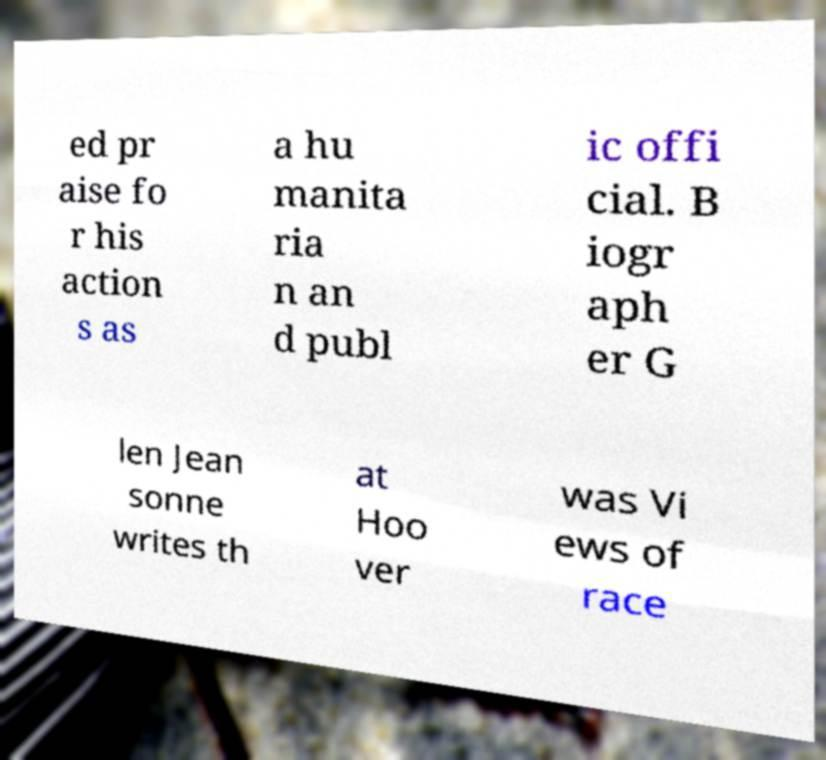I need the written content from this picture converted into text. Can you do that? ed pr aise fo r his action s as a hu manita ria n an d publ ic offi cial. B iogr aph er G len Jean sonne writes th at Hoo ver was Vi ews of race 